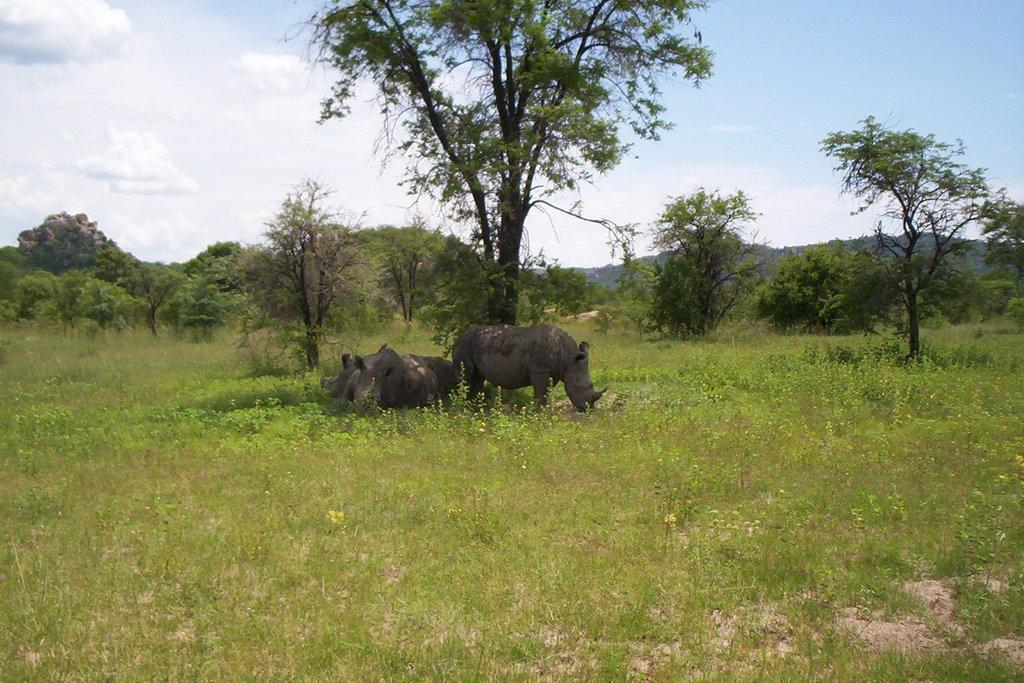What types of living organisms can be seen in the image? There are animals in the image. What can be seen in the background of the image? There are trees, plants, and hills in the image. What is the ground covered with in the image? The land is covered with grass in the image. What is the condition of the sky in the image? The sky is cloudy in the image. How many eyes can be seen on the tramp in the image? There is no tramp present in the image; it features animals, trees, plants, hills, and a cloudy sky. 